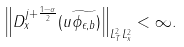Convert formula to latex. <formula><loc_0><loc_0><loc_500><loc_500>\left \| D _ { x } ^ { j + \frac { 1 - \alpha } { 2 } } ( u \widetilde { \phi _ { \epsilon , b } } ) \right \| _ { L ^ { 2 } _ { T } L _ { x } ^ { 2 } } < \infty .</formula> 